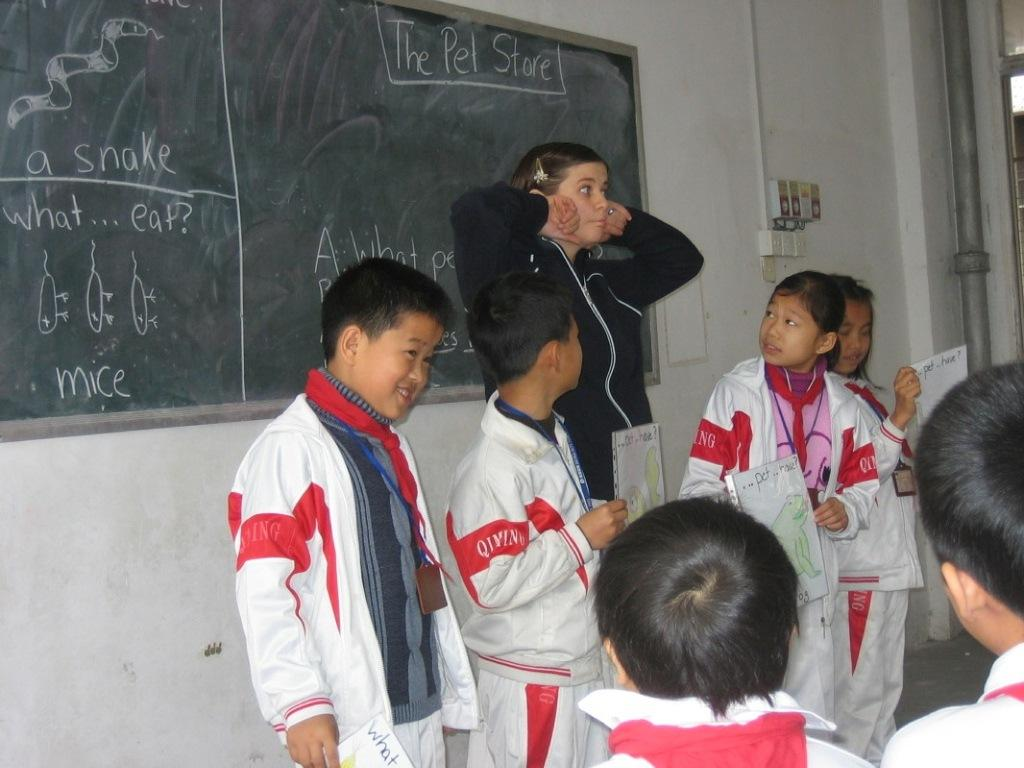<image>
Summarize the visual content of the image. girl in blue making a gesture with her hands and face in front of other students below words the pet store on chalkboard 